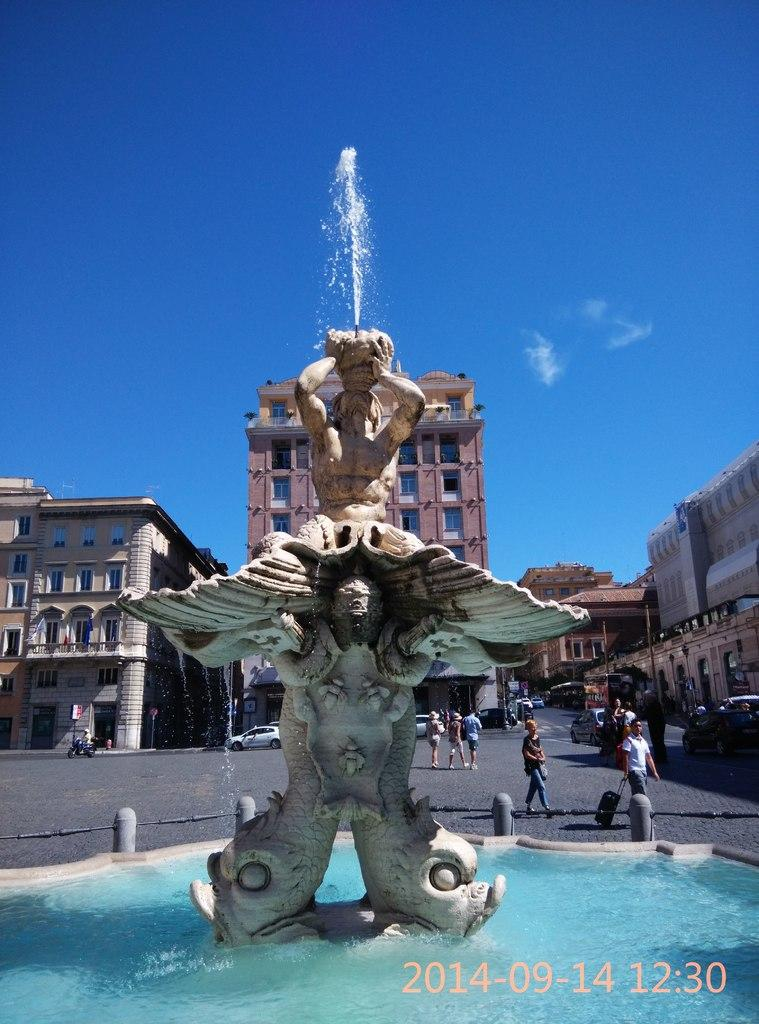What is the main feature in the center of the image? There is a fountain in the center of the image. What can be seen in the distance behind the fountain? There are buildings in the background of the image. Are there any people visible in the image? Yes, there are people on the right side of the image. What type of play apparatus can be seen in the image? There is no play apparatus present in the image. 